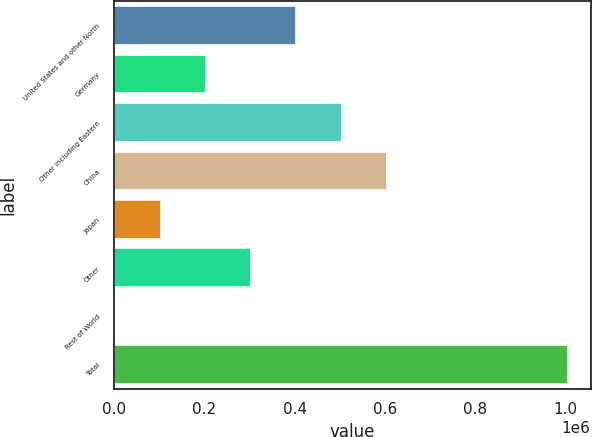Convert chart to OTSL. <chart><loc_0><loc_0><loc_500><loc_500><bar_chart><fcel>United States and other North<fcel>Germany<fcel>Other including Eastern<fcel>China<fcel>Japan<fcel>Other<fcel>Rest of World<fcel>Total<nl><fcel>403753<fcel>202947<fcel>504156<fcel>604560<fcel>102543<fcel>303350<fcel>2140<fcel>1.00617e+06<nl></chart> 